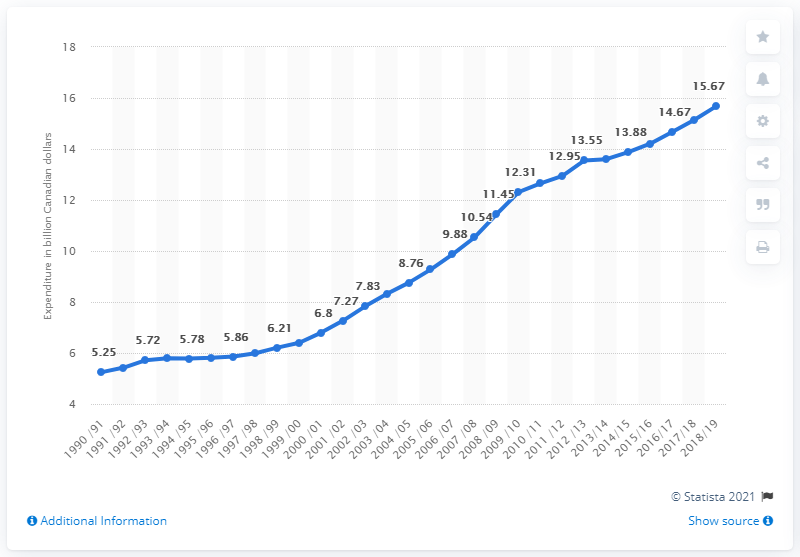Highlight a few significant elements in this photo. In the fiscal year 2019, the total expenditures for police services in Canada was CAD 15.67 million. 